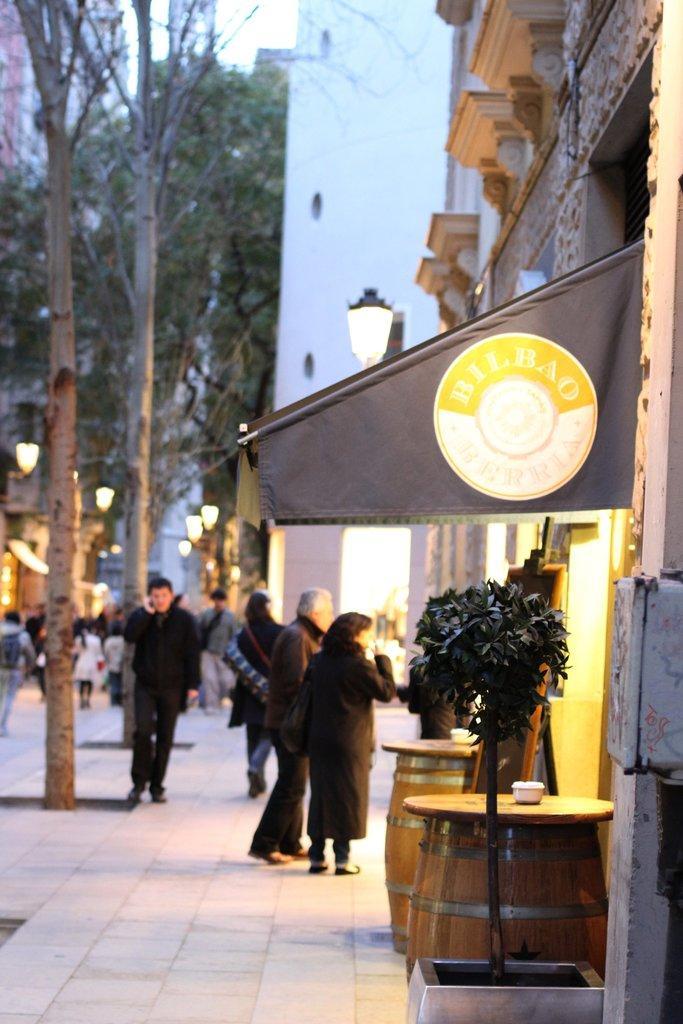Describe this image in one or two sentences. in this picture we can see a group of people where some are walking on foot path and some are walking on road carrying their bags and aside to this foot path we have shops, buildings, trees, drums and on footpath we have trees. 